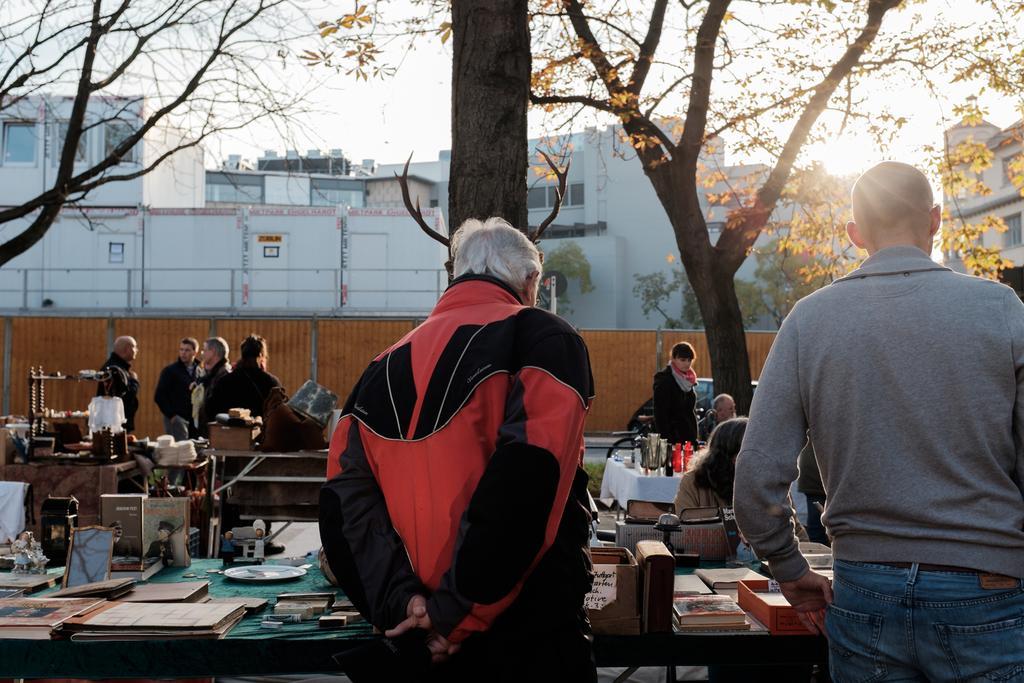Please provide a concise description of this image. As we can see in the image there is a sky, trees, buildings, few people here and there and there is a table. On table there is a plate, photo frames and glasses 